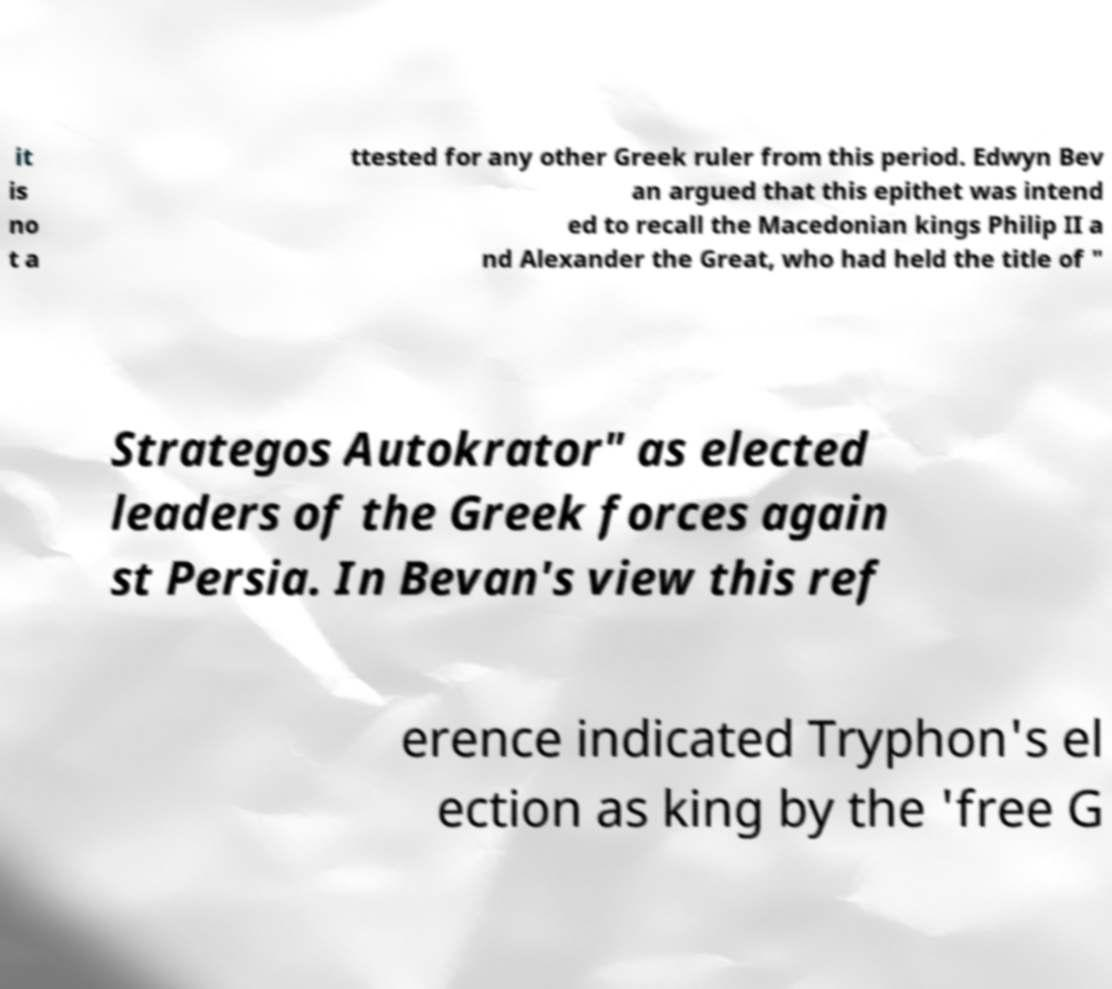Please read and relay the text visible in this image. What does it say? it is no t a ttested for any other Greek ruler from this period. Edwyn Bev an argued that this epithet was intend ed to recall the Macedonian kings Philip II a nd Alexander the Great, who had held the title of " Strategos Autokrator" as elected leaders of the Greek forces again st Persia. In Bevan's view this ref erence indicated Tryphon's el ection as king by the 'free G 